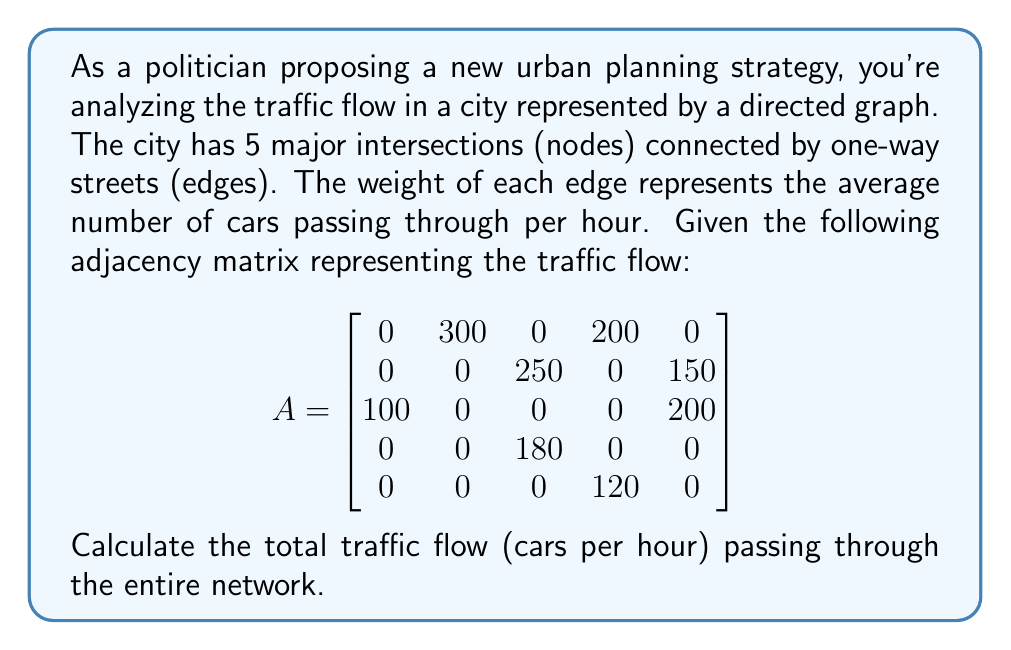Show me your answer to this math problem. To solve this problem, we'll follow these steps:

1) In a directed graph representing traffic flow, the total flow is the sum of all edge weights.

2) In the adjacency matrix, each non-zero entry $a_{ij}$ represents an edge from node i to node j with weight $a_{ij}$.

3) To find the total flow, we need to sum all non-zero entries in the matrix.

4) Let's identify and sum the non-zero entries:
   
   $a_{12} = 300$
   $a_{14} = 200$
   $a_{23} = 250$
   $a_{25} = 150$
   $a_{31} = 100$
   $a_{35} = 200$
   $a_{43} = 180$
   $a_{54} = 120$

5) Now, let's add these values:

   $300 + 200 + 250 + 150 + 100 + 200 + 180 + 120 = 1500$

Therefore, the total traffic flow through the network is 1500 cars per hour.
Answer: 1500 cars/hour 